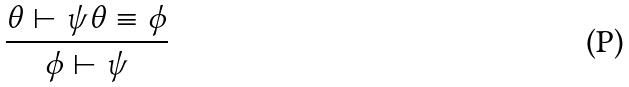Convert formula to latex. <formula><loc_0><loc_0><loc_500><loc_500>\frac { \theta \vdash \psi \theta \equiv \phi } { \phi \vdash \psi }</formula> 